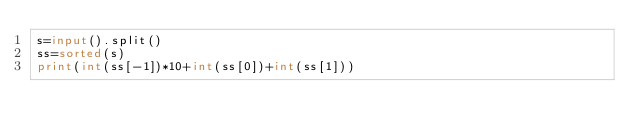Convert code to text. <code><loc_0><loc_0><loc_500><loc_500><_Python_>s=input().split()
ss=sorted(s)
print(int(ss[-1])*10+int(ss[0])+int(ss[1]))</code> 